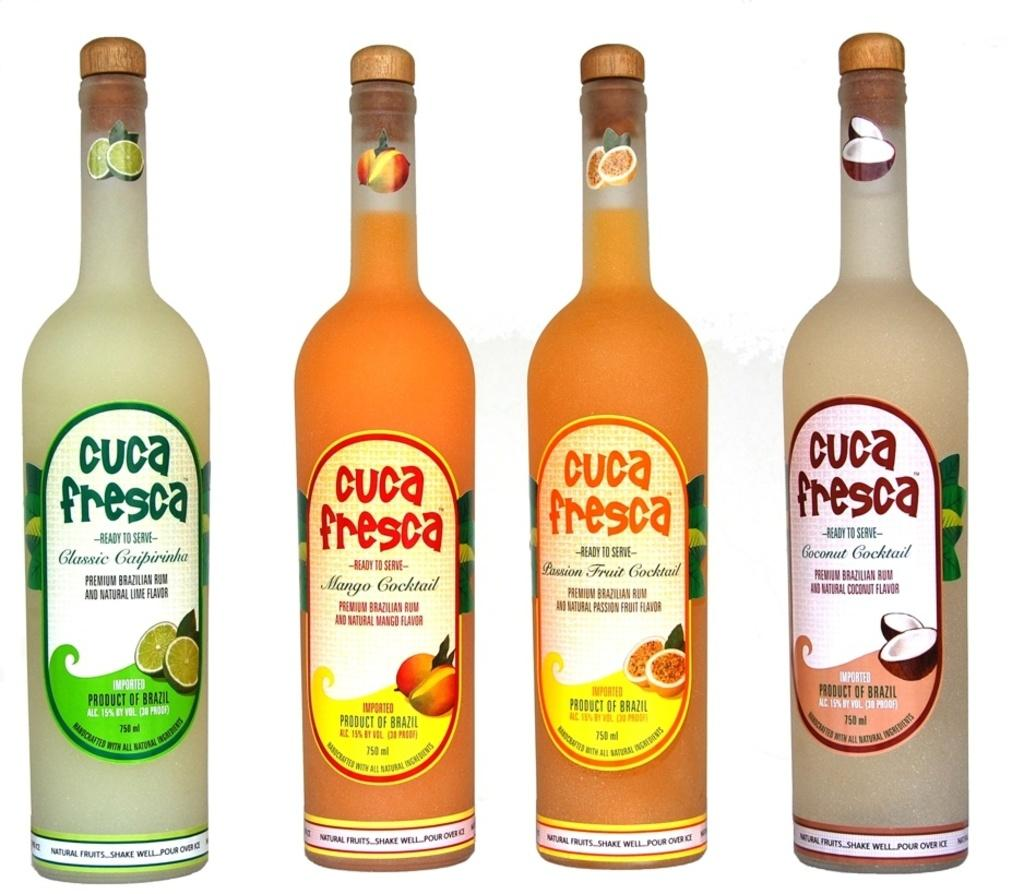<image>
Describe the image concisely. Four bottles of Cuca Fresca cocktails on a white background. 